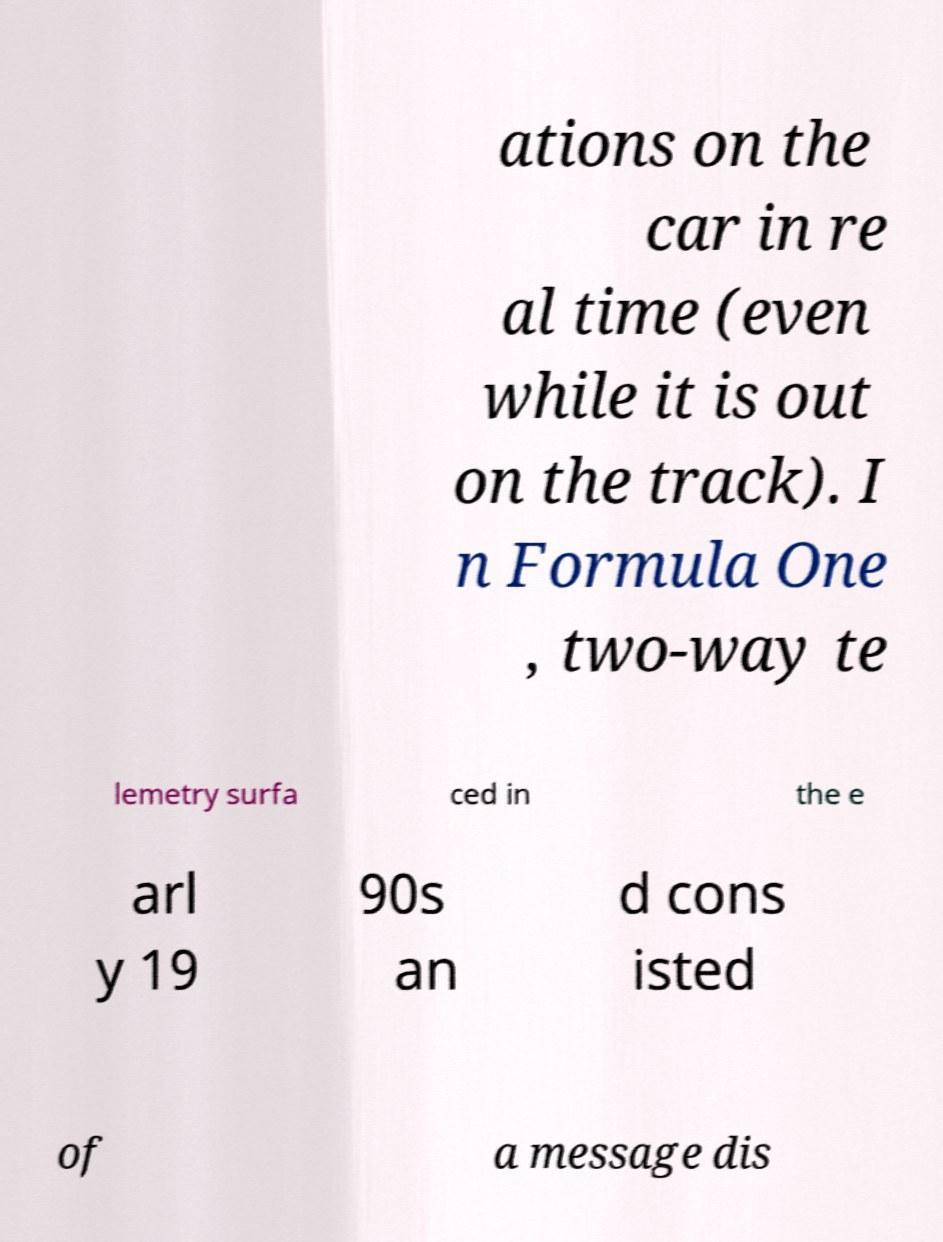Can you read and provide the text displayed in the image?This photo seems to have some interesting text. Can you extract and type it out for me? ations on the car in re al time (even while it is out on the track). I n Formula One , two-way te lemetry surfa ced in the e arl y 19 90s an d cons isted of a message dis 